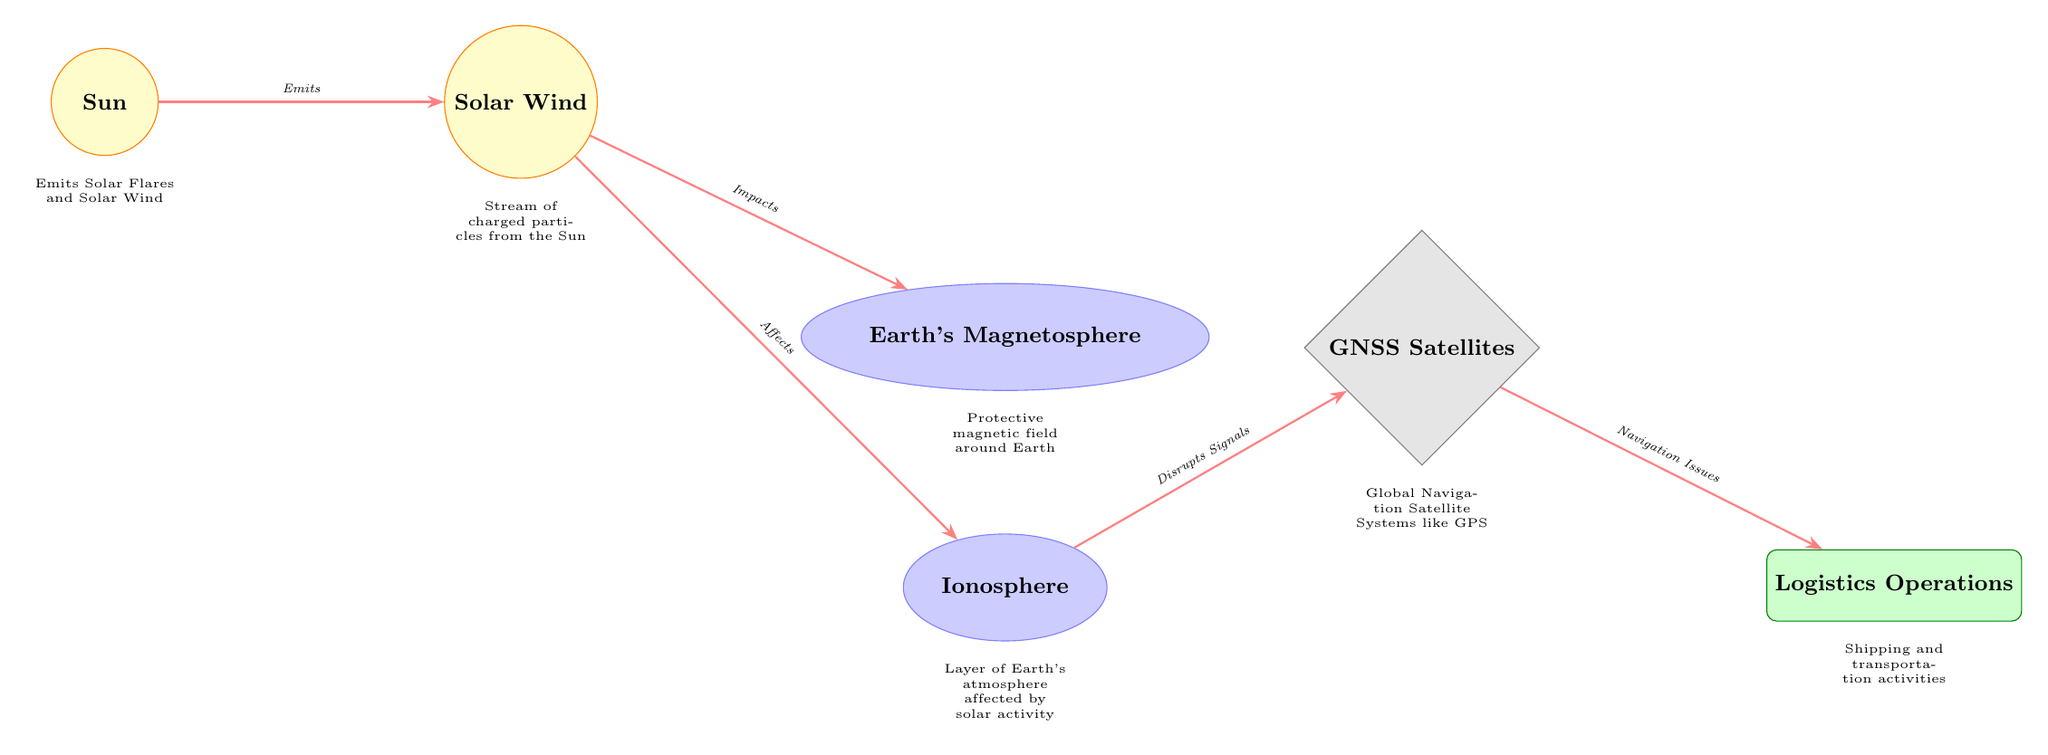What is the first node displayed in the diagram? The diagram starts with the node "Sun," which is positioned at the top left as the source of solar emissions.
Answer: Sun How many main nodes are present in the diagram? The diagram contains a total of six main nodes including the Sun, Solar Wind, Earth's Magnetosphere, Ionosphere, GNSS Satellites, and Logistics Operations.
Answer: 6 What effect does Solar Wind have on Earth's Magnetosphere? According to the diagram, the Solar Wind "Impacts" Earth’s Magnetosphere, which is depicted by the connecting arrow between these two nodes.
Answer: Impacts What does the Ionosphere affect in the diagram? The diagram indicates that the Ionosphere "Disrupts Signals" for the GNSS Satellites, showing a direct effect from the Ionosphere to GNSS Satellites.
Answer: Disrupts Signals Which node represents the Logistics Operations? The Logistics Operations are represented by the node labeled "Logistics Operations," located below the GNSS Satellites in the diagram.
Answer: Logistics Operations What is emitted by the Sun according to the diagram? The diagram states that the Sun "Emits Solar Flares and Solar Wind," detailing the solar phenomena originating from the Sun.
Answer: Solar Flares and Solar Wind How does the Ionosphere impact GNSS Satellites? The diagram shows that the Ionosphere "Disrupts Signals" affecting GNSS Satellites, indicating a breakdown in communication or signal integrity, which can be critical for navigation.
Answer: Disrupts Signals How are GNSS Satellites related to Logistics Operations in this context? The connection in the diagram indicates that GNSS Satellites provide Navigation for Logistics Operations, where issues in satellite navigation directly affect shipping and transportation activities.
Answer: Navigation Issues What is the flow of impact from the Sun to Logistics Operations? The flow starts with the Sun emitting solar activity, which affects Solar Wind, impacting the Magnetosphere, then the Ionosphere, causing disruptions in GNSS signals, leading to navigation issues in Logistics Operations.
Answer: Sun to Logistics Operations through Solar Wind, Magnetosphere, Ionosphere, GNSS Satellites 